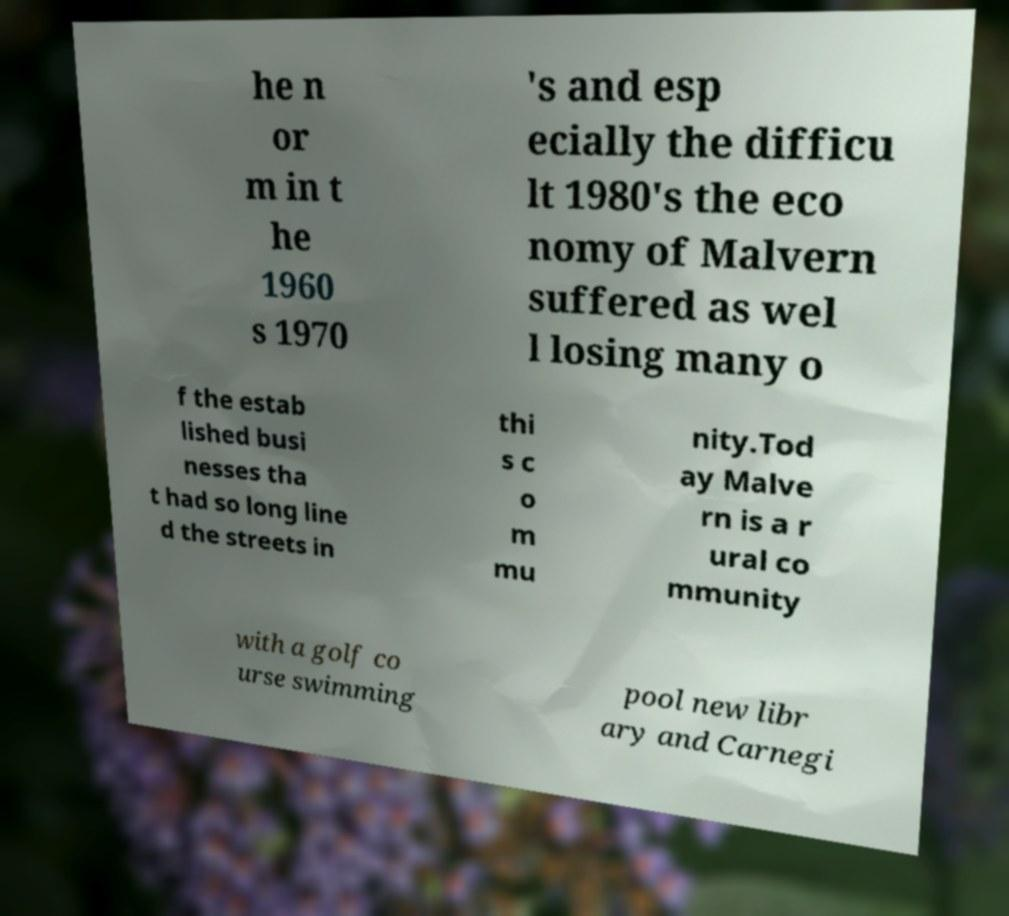For documentation purposes, I need the text within this image transcribed. Could you provide that? he n or m in t he 1960 s 1970 's and esp ecially the difficu lt 1980's the eco nomy of Malvern suffered as wel l losing many o f the estab lished busi nesses tha t had so long line d the streets in thi s c o m mu nity.Tod ay Malve rn is a r ural co mmunity with a golf co urse swimming pool new libr ary and Carnegi 